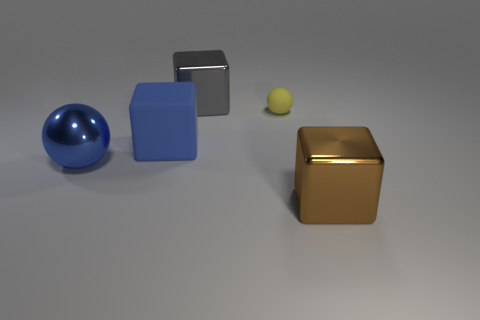If I were to touch the golden cube, what temperature do you think it would be compared to the blue ball? While we can't determine temperature from a visual inspection alone, if the golden cube and the blue ball are made from metals as they appear, the golden cube might feel warmer to the touch due to its color attracting more light absorption. However, the temperature of objects also depends largely on environmental factors and the heat conductivity of the material. 